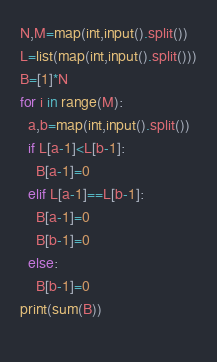Convert code to text. <code><loc_0><loc_0><loc_500><loc_500><_Python_>N,M=map(int,input().split())
L=list(map(int,input().split()))
B=[1]*N
for i in range(M):
  a,b=map(int,input().split())
  if L[a-1]<L[b-1]:
    B[a-1]=0
  elif L[a-1]==L[b-1]:
    B[a-1]=0
    B[b-1]=0
  else:
    B[b-1]=0
print(sum(B))
  </code> 